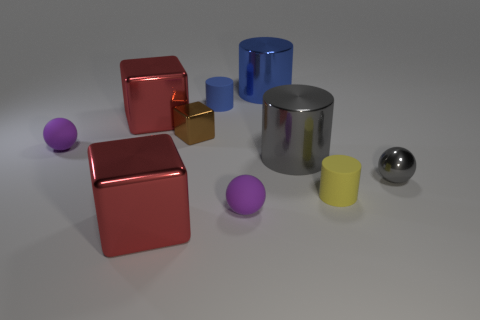Do the small metallic sphere and the metallic cylinder in front of the small block have the same color? yes 